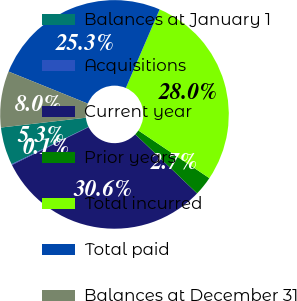<chart> <loc_0><loc_0><loc_500><loc_500><pie_chart><fcel>Balances at January 1<fcel>Acquisitions<fcel>Current year<fcel>Prior years<fcel>Total incurred<fcel>Total paid<fcel>Balances at December 31<nl><fcel>5.34%<fcel>0.12%<fcel>30.56%<fcel>2.73%<fcel>27.95%<fcel>25.34%<fcel>7.95%<nl></chart> 